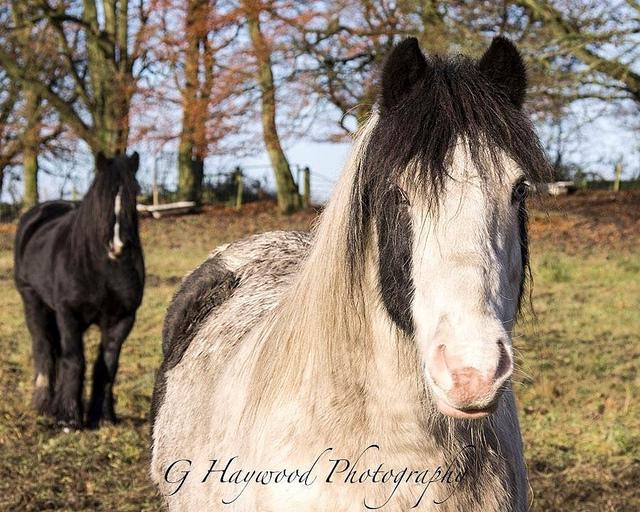How many horses are there?
Short answer required. 2. Should this horse have its hair in braids?
Concise answer only. No. What color is the horse in the background?
Concise answer only. Black. Are these horses in a meadow?
Keep it brief. Yes. 